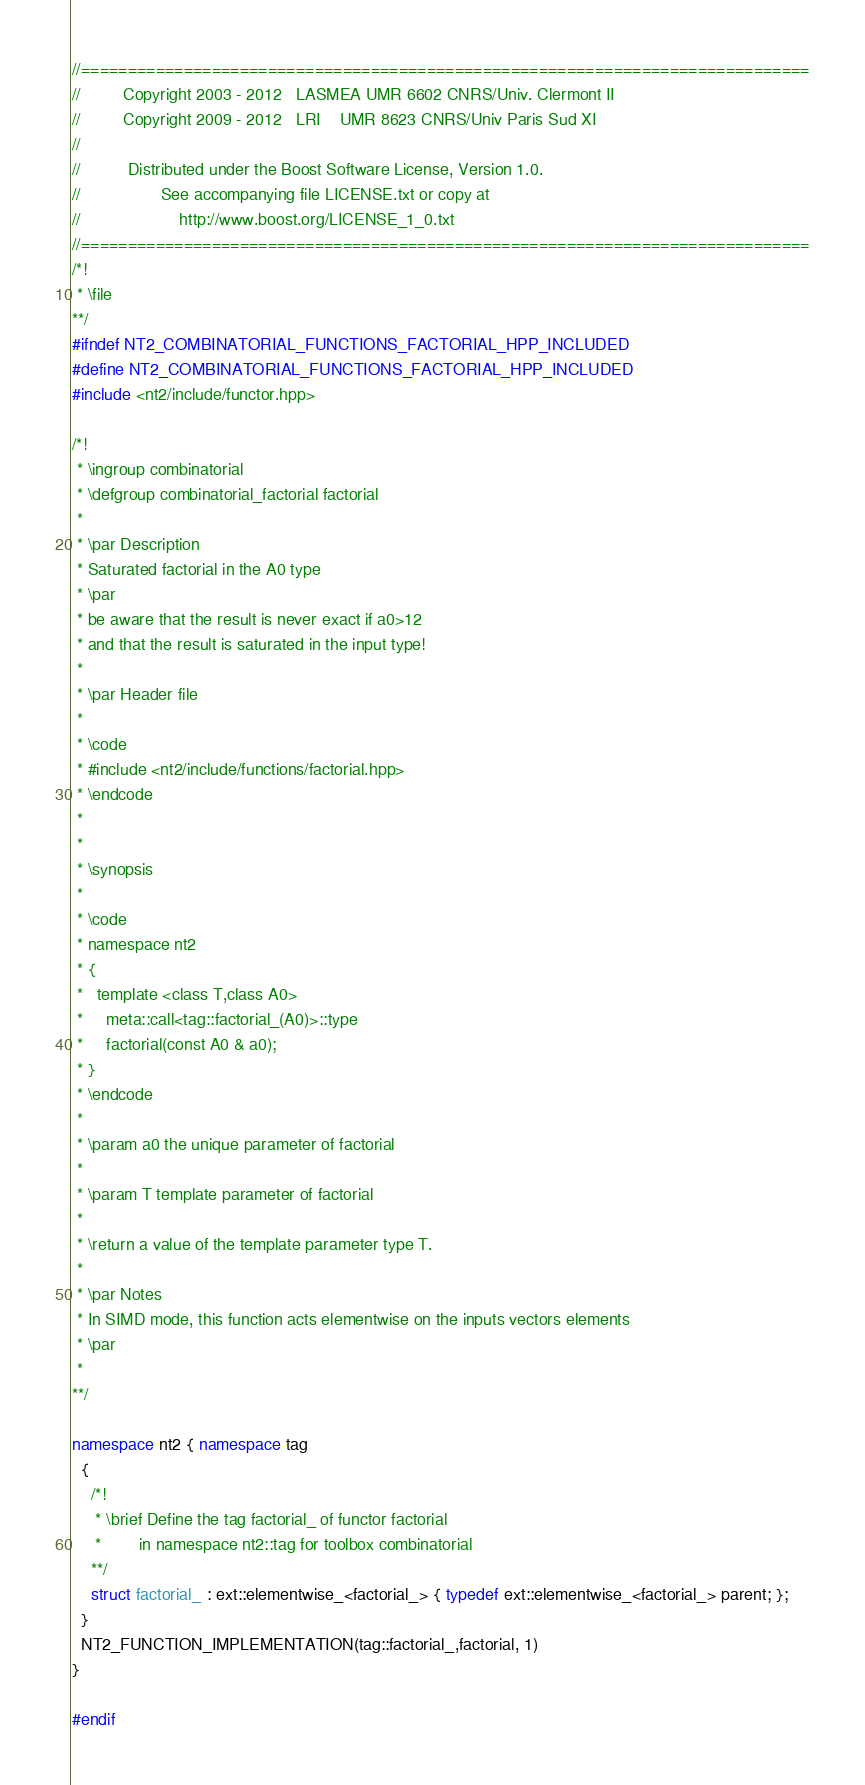Convert code to text. <code><loc_0><loc_0><loc_500><loc_500><_C++_>//==============================================================================
//         Copyright 2003 - 2012   LASMEA UMR 6602 CNRS/Univ. Clermont II
//         Copyright 2009 - 2012   LRI    UMR 8623 CNRS/Univ Paris Sud XI
//
//          Distributed under the Boost Software License, Version 1.0.
//                 See accompanying file LICENSE.txt or copy at
//                     http://www.boost.org/LICENSE_1_0.txt
//==============================================================================
/*!
 * \file
**/
#ifndef NT2_COMBINATORIAL_FUNCTIONS_FACTORIAL_HPP_INCLUDED
#define NT2_COMBINATORIAL_FUNCTIONS_FACTORIAL_HPP_INCLUDED
#include <nt2/include/functor.hpp>

/*!
 * \ingroup combinatorial
 * \defgroup combinatorial_factorial factorial
 *
 * \par Description
 * Saturated factorial in the A0 type
 * \par
 * be aware that the result is never exact if a0>12
 * and that the result is saturated in the input type!
 *
 * \par Header file
 *
 * \code
 * #include <nt2/include/functions/factorial.hpp>
 * \endcode
 *
 *
 * \synopsis
 *
 * \code
 * namespace nt2
 * {
 *   template <class T,class A0>
 *     meta::call<tag::factorial_(A0)>::type
 *     factorial(const A0 & a0);
 * }
 * \endcode
 *
 * \param a0 the unique parameter of factorial
 *
 * \param T template parameter of factorial
 *
 * \return a value of the template parameter type T.
 *
 * \par Notes
 * In SIMD mode, this function acts elementwise on the inputs vectors elements
 * \par
 *
**/

namespace nt2 { namespace tag
  {
    /*!
     * \brief Define the tag factorial_ of functor factorial
     *        in namespace nt2::tag for toolbox combinatorial
    **/
    struct factorial_ : ext::elementwise_<factorial_> { typedef ext::elementwise_<factorial_> parent; };
  }
  NT2_FUNCTION_IMPLEMENTATION(tag::factorial_,factorial, 1)
}

#endif

</code> 